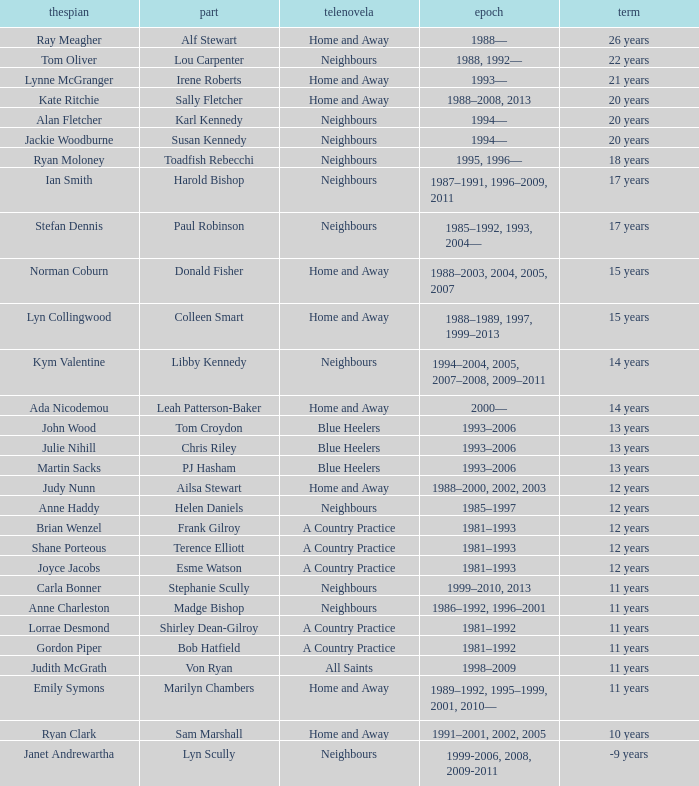How long did Joyce Jacobs portray her character on her show? 12 years. Give me the full table as a dictionary. {'header': ['thespian', 'part', 'telenovela', 'epoch', 'term'], 'rows': [['Ray Meagher', 'Alf Stewart', 'Home and Away', '1988—', '26 years'], ['Tom Oliver', 'Lou Carpenter', 'Neighbours', '1988, 1992—', '22 years'], ['Lynne McGranger', 'Irene Roberts', 'Home and Away', '1993—', '21 years'], ['Kate Ritchie', 'Sally Fletcher', 'Home and Away', '1988–2008, 2013', '20 years'], ['Alan Fletcher', 'Karl Kennedy', 'Neighbours', '1994—', '20 years'], ['Jackie Woodburne', 'Susan Kennedy', 'Neighbours', '1994—', '20 years'], ['Ryan Moloney', 'Toadfish Rebecchi', 'Neighbours', '1995, 1996—', '18 years'], ['Ian Smith', 'Harold Bishop', 'Neighbours', '1987–1991, 1996–2009, 2011', '17 years'], ['Stefan Dennis', 'Paul Robinson', 'Neighbours', '1985–1992, 1993, 2004—', '17 years'], ['Norman Coburn', 'Donald Fisher', 'Home and Away', '1988–2003, 2004, 2005, 2007', '15 years'], ['Lyn Collingwood', 'Colleen Smart', 'Home and Away', '1988–1989, 1997, 1999–2013', '15 years'], ['Kym Valentine', 'Libby Kennedy', 'Neighbours', '1994–2004, 2005, 2007–2008, 2009–2011', '14 years'], ['Ada Nicodemou', 'Leah Patterson-Baker', 'Home and Away', '2000—', '14 years'], ['John Wood', 'Tom Croydon', 'Blue Heelers', '1993–2006', '13 years'], ['Julie Nihill', 'Chris Riley', 'Blue Heelers', '1993–2006', '13 years'], ['Martin Sacks', 'PJ Hasham', 'Blue Heelers', '1993–2006', '13 years'], ['Judy Nunn', 'Ailsa Stewart', 'Home and Away', '1988–2000, 2002, 2003', '12 years'], ['Anne Haddy', 'Helen Daniels', 'Neighbours', '1985–1997', '12 years'], ['Brian Wenzel', 'Frank Gilroy', 'A Country Practice', '1981–1993', '12 years'], ['Shane Porteous', 'Terence Elliott', 'A Country Practice', '1981–1993', '12 years'], ['Joyce Jacobs', 'Esme Watson', 'A Country Practice', '1981–1993', '12 years'], ['Carla Bonner', 'Stephanie Scully', 'Neighbours', '1999–2010, 2013', '11 years'], ['Anne Charleston', 'Madge Bishop', 'Neighbours', '1986–1992, 1996–2001', '11 years'], ['Lorrae Desmond', 'Shirley Dean-Gilroy', 'A Country Practice', '1981–1992', '11 years'], ['Gordon Piper', 'Bob Hatfield', 'A Country Practice', '1981–1992', '11 years'], ['Judith McGrath', 'Von Ryan', 'All Saints', '1998–2009', '11 years'], ['Emily Symons', 'Marilyn Chambers', 'Home and Away', '1989–1992, 1995–1999, 2001, 2010—', '11 years'], ['Ryan Clark', 'Sam Marshall', 'Home and Away', '1991–2001, 2002, 2005', '10 years'], ['Janet Andrewartha', 'Lyn Scully', 'Neighbours', '1999-2006, 2008, 2009-2011', '-9 years']]} 